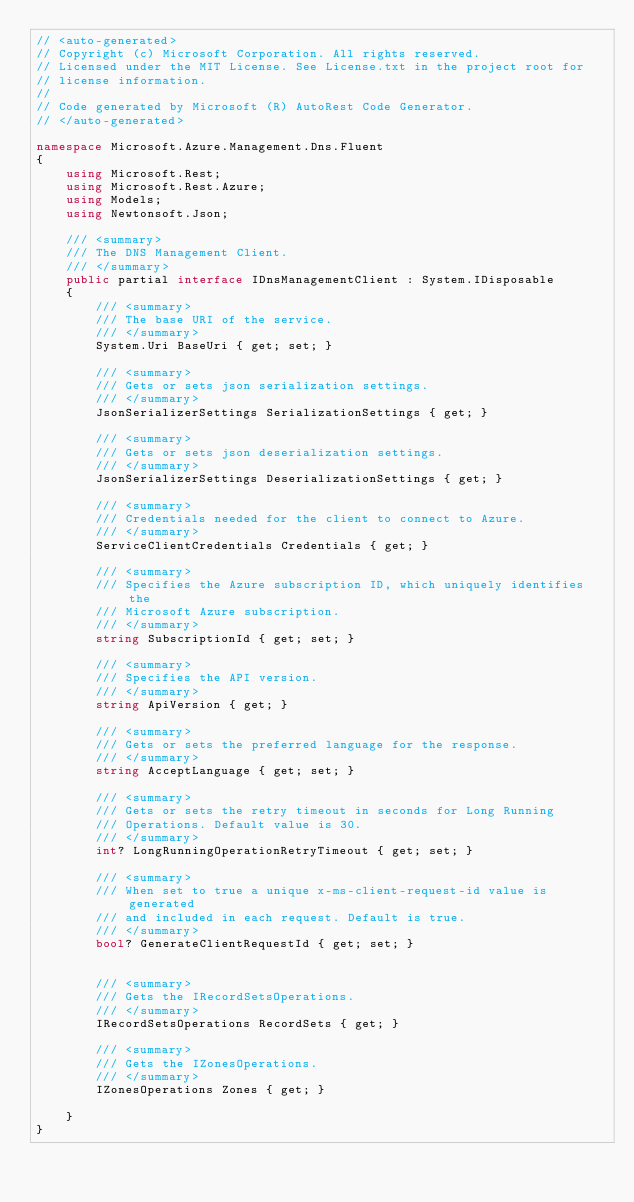<code> <loc_0><loc_0><loc_500><loc_500><_C#_>// <auto-generated>
// Copyright (c) Microsoft Corporation. All rights reserved.
// Licensed under the MIT License. See License.txt in the project root for
// license information.
//
// Code generated by Microsoft (R) AutoRest Code Generator.
// </auto-generated>

namespace Microsoft.Azure.Management.Dns.Fluent
{
    using Microsoft.Rest;
    using Microsoft.Rest.Azure;
    using Models;
    using Newtonsoft.Json;

    /// <summary>
    /// The DNS Management Client.
    /// </summary>
    public partial interface IDnsManagementClient : System.IDisposable
    {
        /// <summary>
        /// The base URI of the service.
        /// </summary>
        System.Uri BaseUri { get; set; }

        /// <summary>
        /// Gets or sets json serialization settings.
        /// </summary>
        JsonSerializerSettings SerializationSettings { get; }

        /// <summary>
        /// Gets or sets json deserialization settings.
        /// </summary>
        JsonSerializerSettings DeserializationSettings { get; }

        /// <summary>
        /// Credentials needed for the client to connect to Azure.
        /// </summary>
        ServiceClientCredentials Credentials { get; }

        /// <summary>
        /// Specifies the Azure subscription ID, which uniquely identifies the
        /// Microsoft Azure subscription.
        /// </summary>
        string SubscriptionId { get; set; }

        /// <summary>
        /// Specifies the API version.
        /// </summary>
        string ApiVersion { get; }

        /// <summary>
        /// Gets or sets the preferred language for the response.
        /// </summary>
        string AcceptLanguage { get; set; }

        /// <summary>
        /// Gets or sets the retry timeout in seconds for Long Running
        /// Operations. Default value is 30.
        /// </summary>
        int? LongRunningOperationRetryTimeout { get; set; }

        /// <summary>
        /// When set to true a unique x-ms-client-request-id value is generated
        /// and included in each request. Default is true.
        /// </summary>
        bool? GenerateClientRequestId { get; set; }


        /// <summary>
        /// Gets the IRecordSetsOperations.
        /// </summary>
        IRecordSetsOperations RecordSets { get; }

        /// <summary>
        /// Gets the IZonesOperations.
        /// </summary>
        IZonesOperations Zones { get; }

    }
}
</code> 